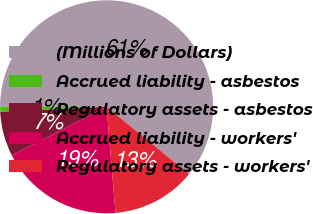Convert chart. <chart><loc_0><loc_0><loc_500><loc_500><pie_chart><fcel>(Millions of Dollars)<fcel>Accrued liability - asbestos<fcel>Regulatory assets - asbestos<fcel>Accrued liability - workers'<fcel>Regulatory assets - workers'<nl><fcel>60.89%<fcel>0.76%<fcel>6.77%<fcel>18.8%<fcel>12.78%<nl></chart> 